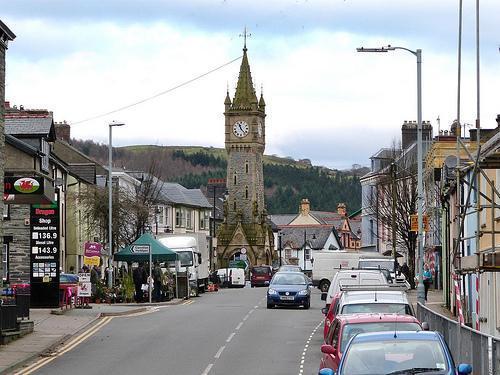How many clocks can be seen on the building?
Give a very brief answer. 2. How many of the buildings are clock towers?
Give a very brief answer. 1. 